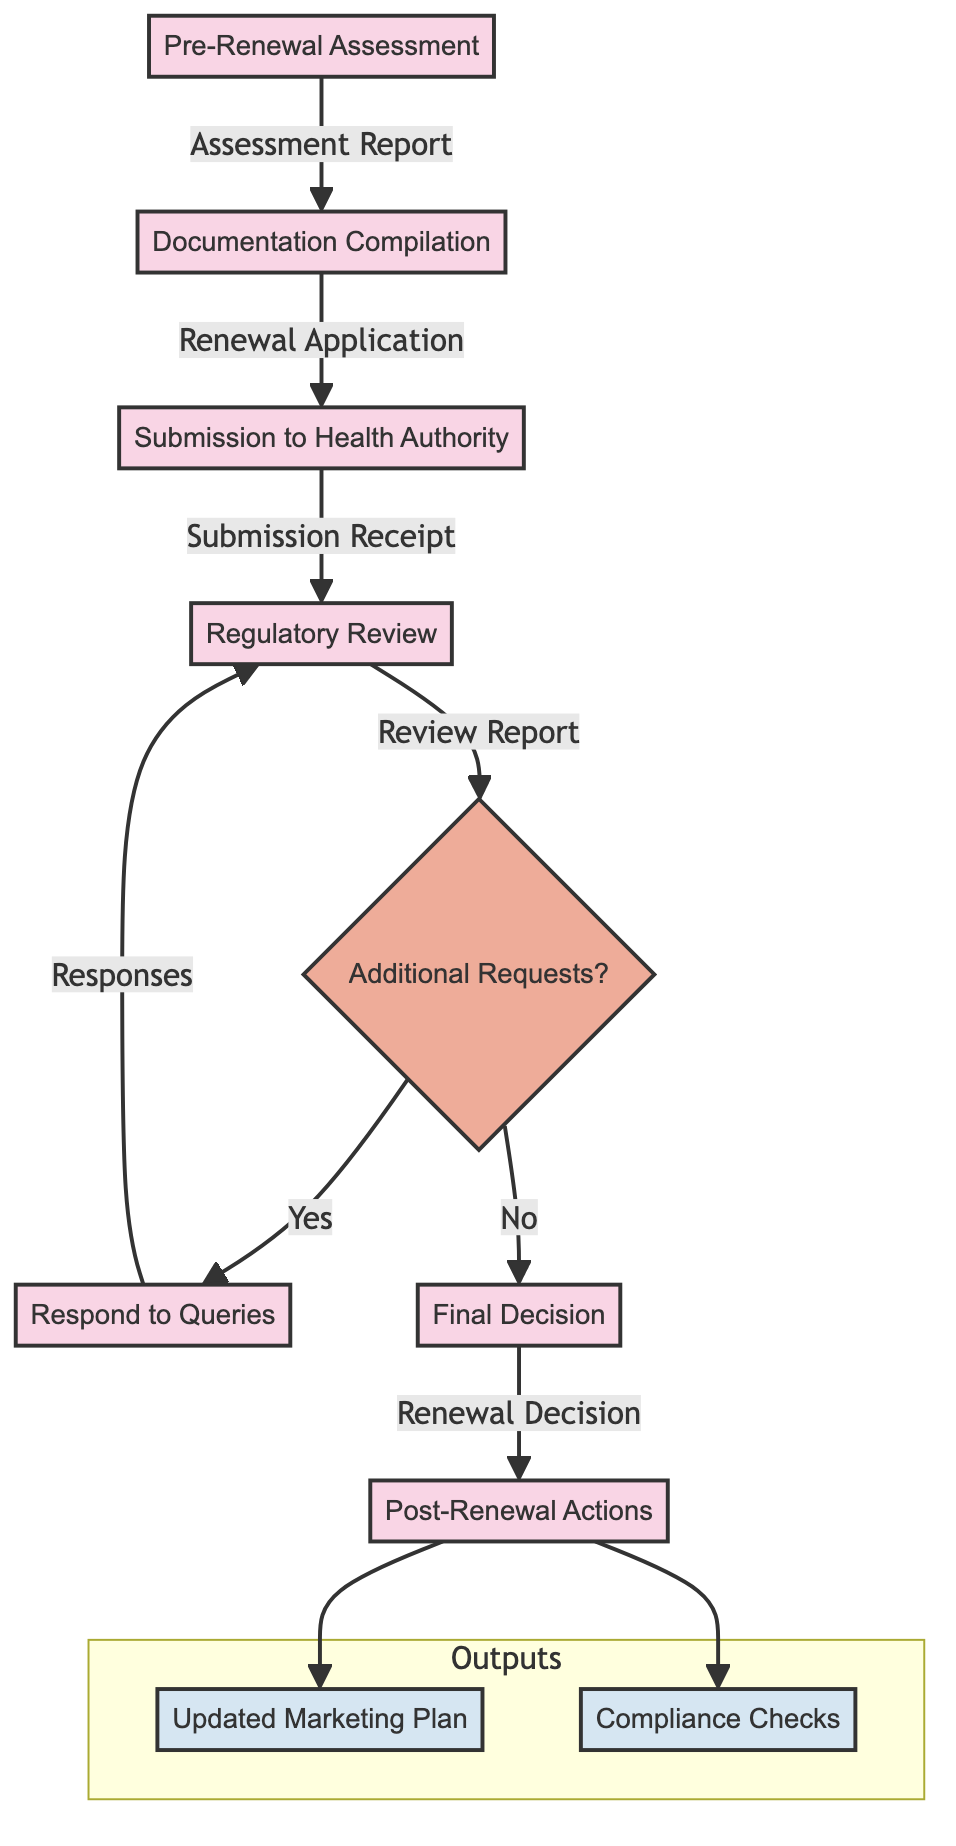What is the first step in the process? The first step in the process is indicated as the initial node in the diagram. It is labeled "Pre-Renewal Assessment."
Answer: Pre-Renewal Assessment How many steps are in the drug marketing authorization renewal process? To find the number of steps, I can count the nodes in the flowchart, which represent the steps. There are seven steps total.
Answer: 7 What is the output of the "Regulatory Review" step? The output of the "Regulatory Review" step is found directly connected to that node in the diagram. The outputs noted are "Review Report" and "Additional Requests," with the focus here on the review report.
Answer: Review Report What happens if additional requests are received after the Regulatory Review? If additional requests are received, the flow shows a decision node leading to "Respond to Queries." This indicates that responses to those requests must be completed before proceeding.
Answer: Respond to Queries What are the final outputs of the post-renewal actions? The final outputs of the "Post-Renewal Actions" node show two significant outcomes connected to it in the output subgraph, which are the updated marketing plan and compliance checks.
Answer: Updated Marketing Plan, Compliance Checks How does the process proceed if no additional requests are made during the Regulatory Review? When no additional requests are indicated, the process continues directly to the "Final Decision" step, as depicted by the arrow connecting the two nodes.
Answer: Final Decision What role does the "Regulatory Affairs" department play in the process? The "Regulatory Affairs" department is involved in multiple steps throughout the process, specifically: Pre-Renewal Assessment, Documentation Compilation, Submission to Health Authority, and Respond to Queries, indicating its crucial role in regulatory compliance.
Answer: Multiple roles What is the decision point in the process, and what question does it ask? The decision point in the process is denoted by the diamond-shaped node labeled "Additional Requests?" This represents a question that assesses whether there are any additional requests to address before the process can move forward.
Answer: Additional Requests? 